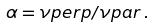<formula> <loc_0><loc_0><loc_500><loc_500>\alpha = \nu p e r p / \nu p a r \, .</formula> 